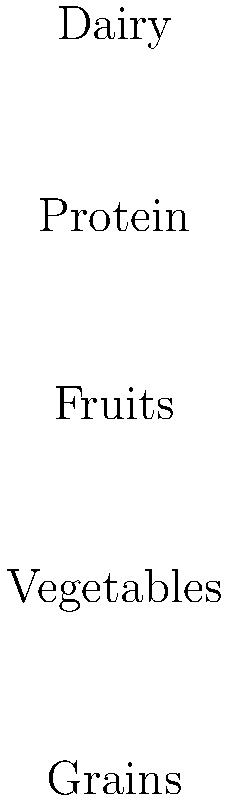Based on the food pyramid and bar chart showing popular teenage snacks, which item in the bar chart should be increased in a teenager's diet to better align with the food pyramid recommendations? To answer this question, we need to analyze both the food pyramid and the bar chart:

1. The food pyramid shows the recommended proportions of different food groups:
   - Grains (largest portion at the base)
   - Vegetables (second-largest portion)
   - Fruits (middle portion)
   - Protein (smaller portion)
   - Dairy (smallest portion at the top)

2. The bar chart shows the consumption of popular teenage snacks:
   - Chips: 15%
   - Soda: 25%
   - Pizza: 35%
   - Fruit: 10%
   - Yogurt: 15%

3. Comparing the two:
   - Chips and soda are not essential food groups and should be limited.
   - Pizza contains grains and sometimes vegetables, but it's often high in fat and should be consumed in moderation.
   - Fruit is an essential food group but has low consumption (10%).
   - Yogurt represents the dairy group, which is important but should be consumed in smaller amounts.

4. The food pyramid emphasizes fruits as a significant portion of a balanced diet, but the bar chart shows that fruit consumption is the lowest among the given options.

5. Therefore, to better align with the food pyramid recommendations, fruit consumption should be increased in a teenager's diet.
Answer: Fruit 